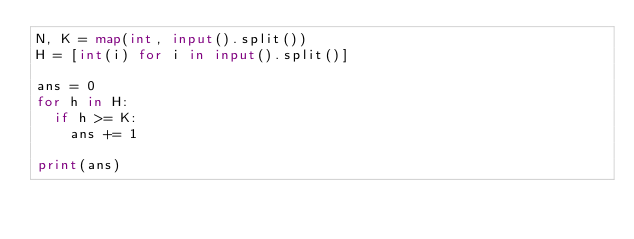<code> <loc_0><loc_0><loc_500><loc_500><_Python_>N, K = map(int, input().split())
H = [int(i) for i in input().split()]

ans = 0
for h in H:
  if h >= K:
    ans += 1
    
print(ans)</code> 